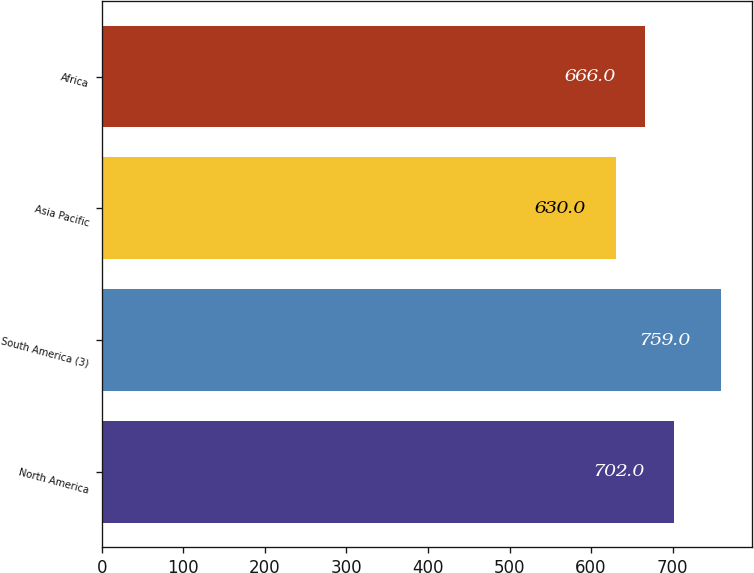<chart> <loc_0><loc_0><loc_500><loc_500><bar_chart><fcel>North America<fcel>South America (3)<fcel>Asia Pacific<fcel>Africa<nl><fcel>702<fcel>759<fcel>630<fcel>666<nl></chart> 